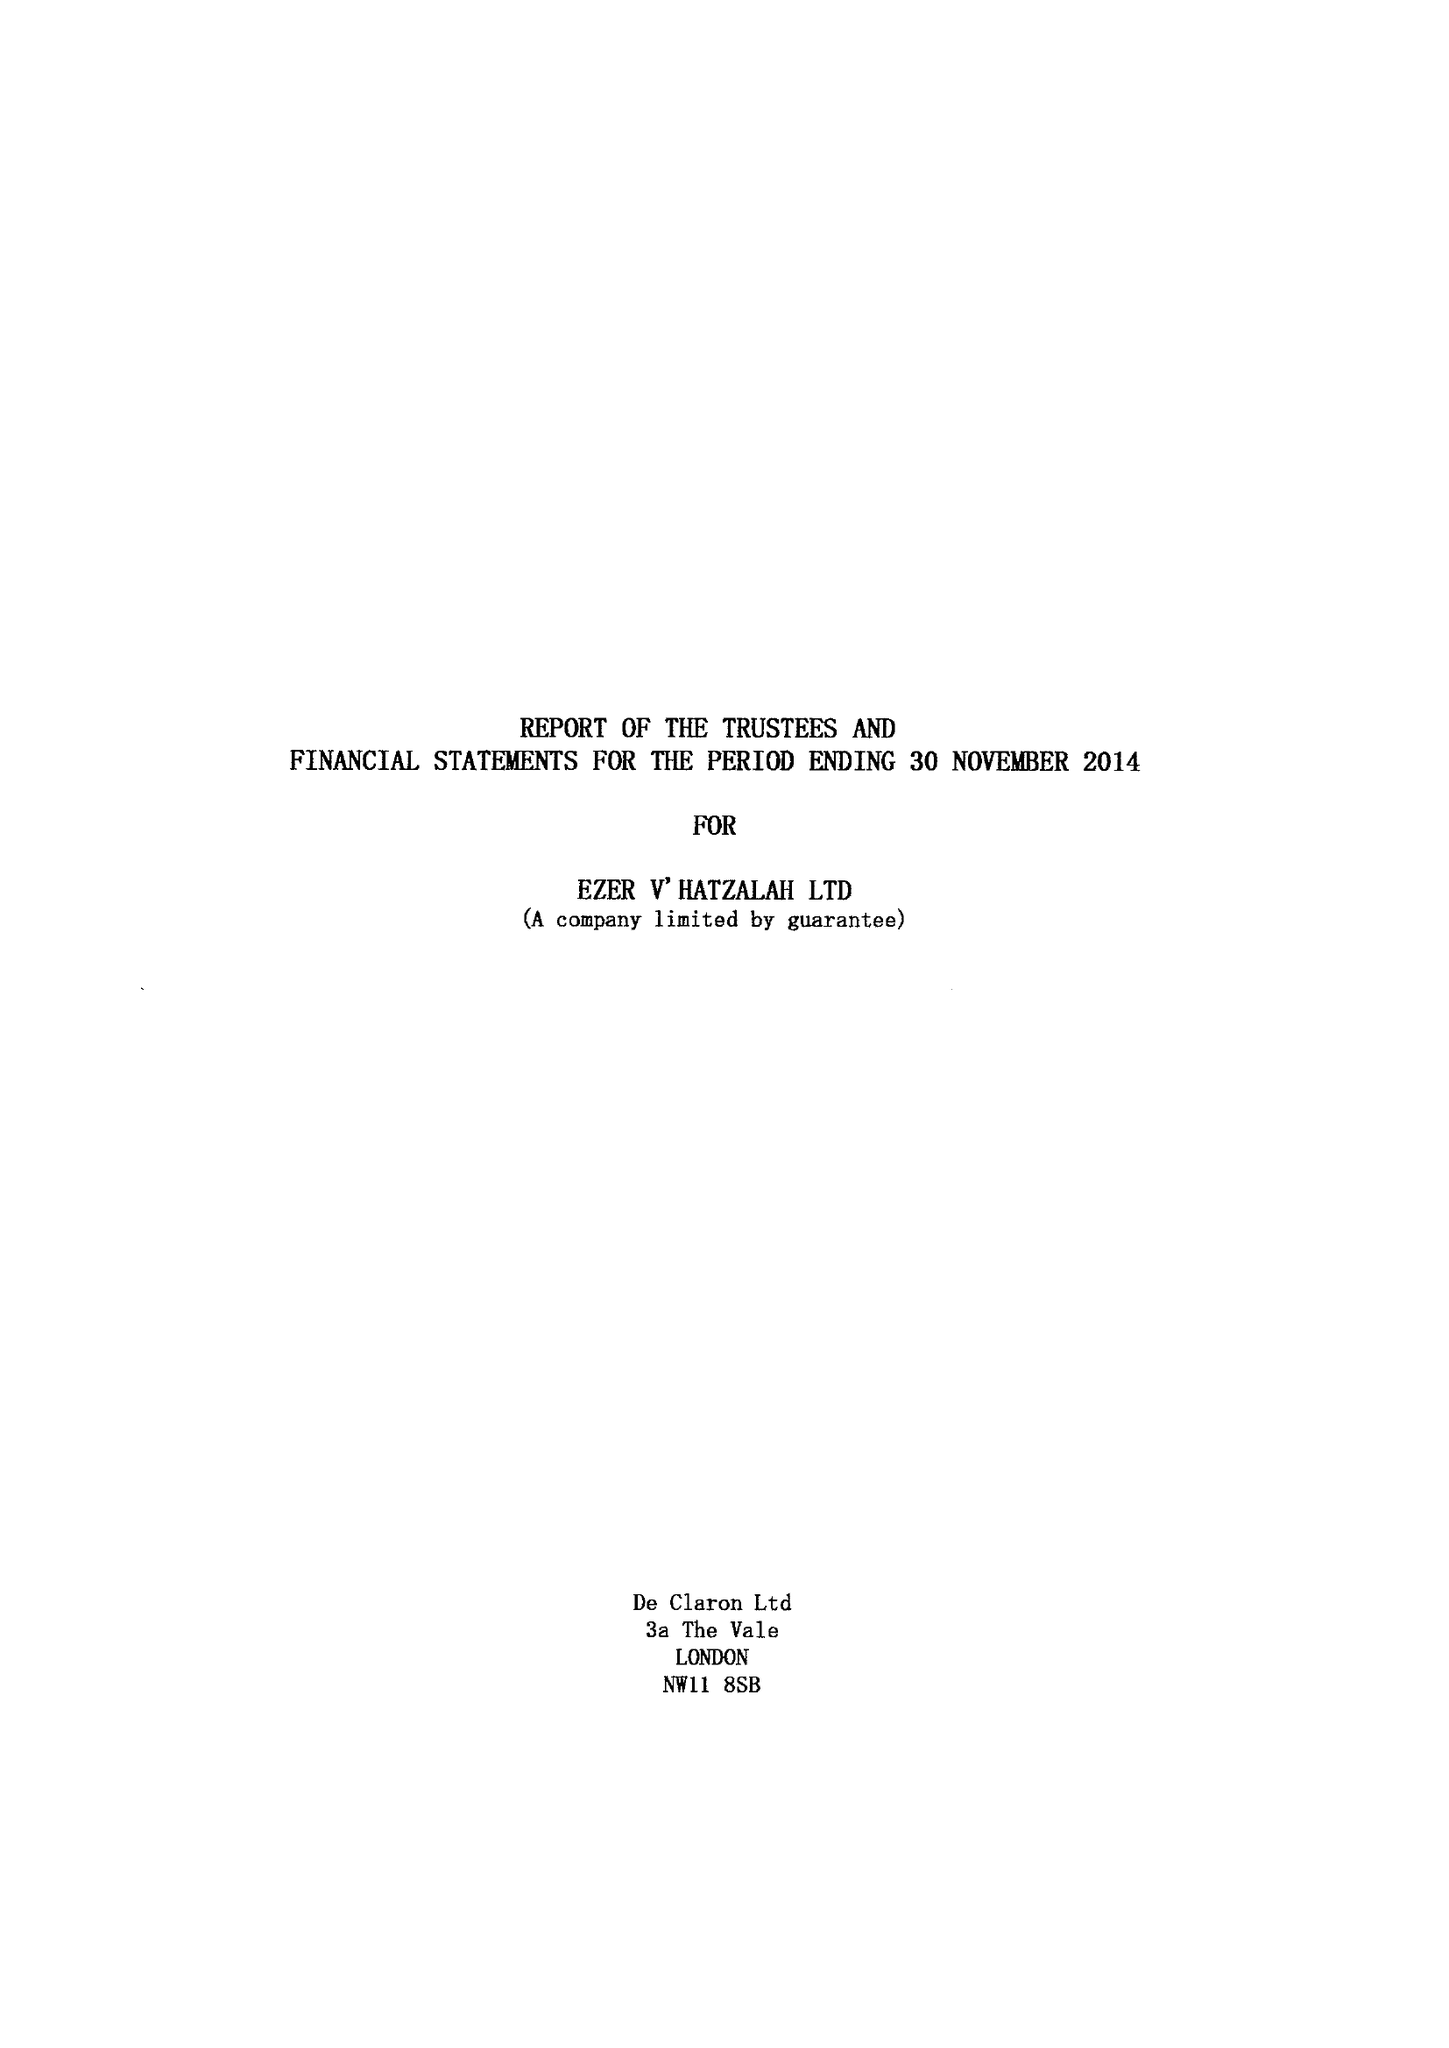What is the value for the address__street_line?
Answer the question using a single word or phrase. 52 EAST BANK 